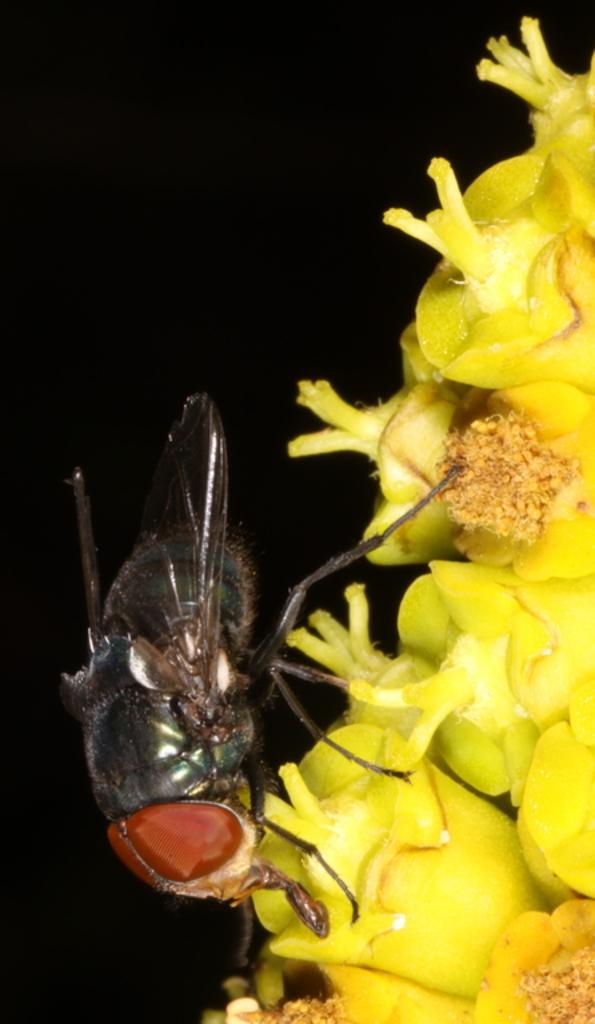What is present on the flower in the image? There is an insect on the flower in the image. What colors can be seen on the insect? The insect has black and brown colors. What color is the flower that the insect is on? The flower has a yellow color. What can be observed about the background of the image? The background of the image is dark. How many dogs are visible in the image? There are no dogs present in the image. What effect does the insect have on the rice in the image? There is no rice present in the image, and therefore no effect can be observed. 